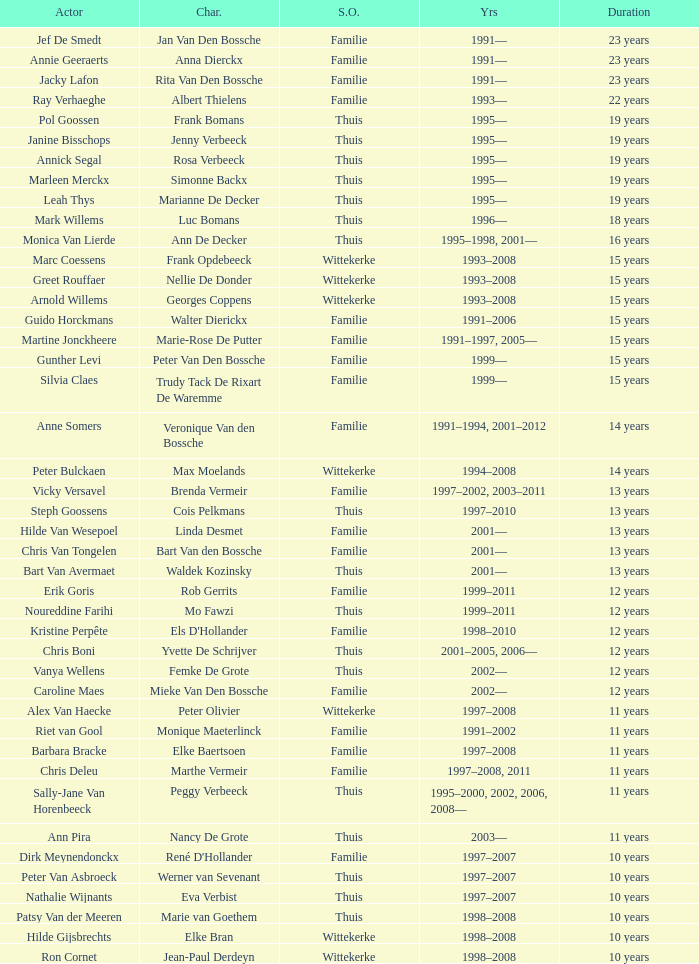What character did Vicky Versavel play for 13 years? Brenda Vermeir. 